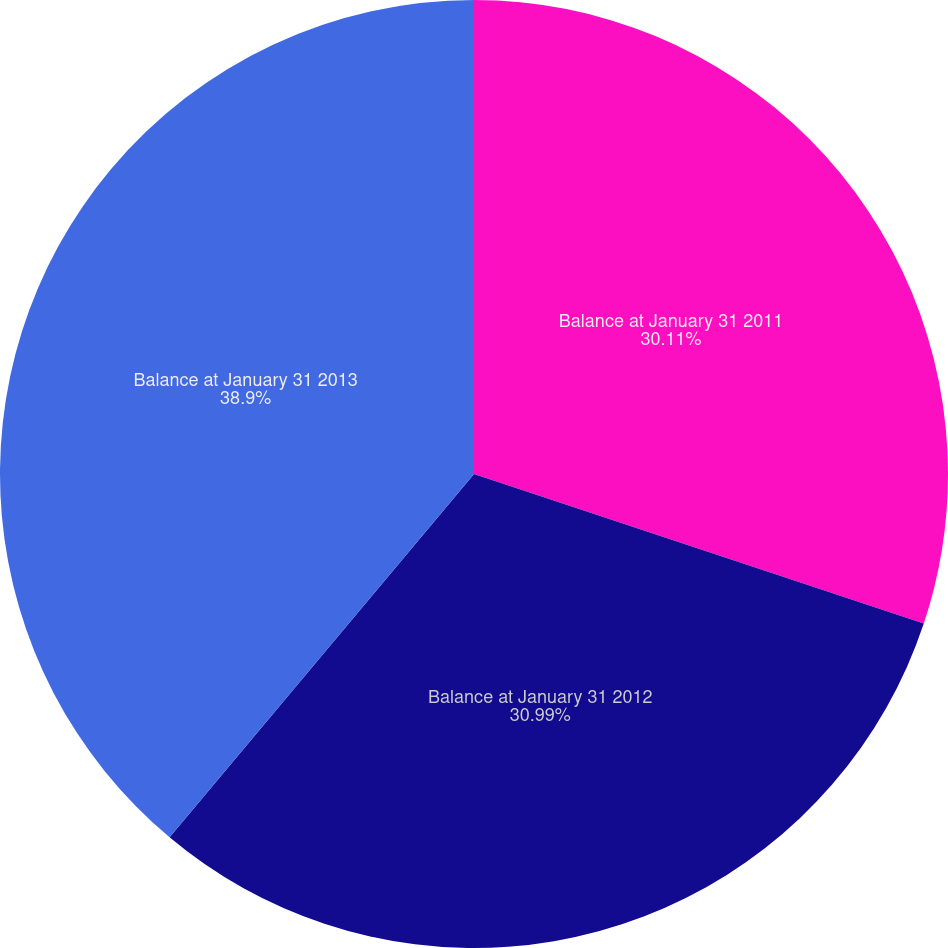<chart> <loc_0><loc_0><loc_500><loc_500><pie_chart><fcel>Balance at January 31 2011<fcel>Balance at January 31 2012<fcel>Balance at January 31 2013<nl><fcel>30.11%<fcel>30.99%<fcel>38.9%<nl></chart> 